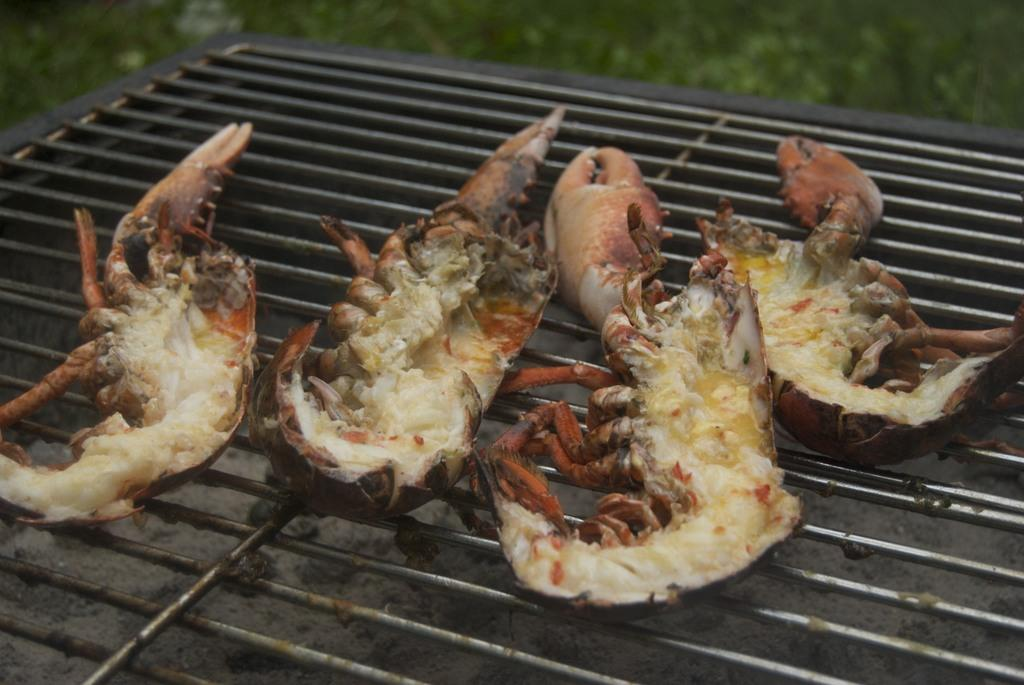What is the main object in the image? There is a grill in the image. What is being cooked on the grill? There are crabs on the grill. What type of vegetation can be seen in the image? Plants are visible towards the top of the image. How would you describe the clarity of the top of the image? The top of the image is blurred. What color crayon is being used to draw on the trail in the image? There is no trail or crayon present in the image. How are the crabs connected to the grill in the image? The crabs are not connected to the grill; they are simply placed on it for cooking. 